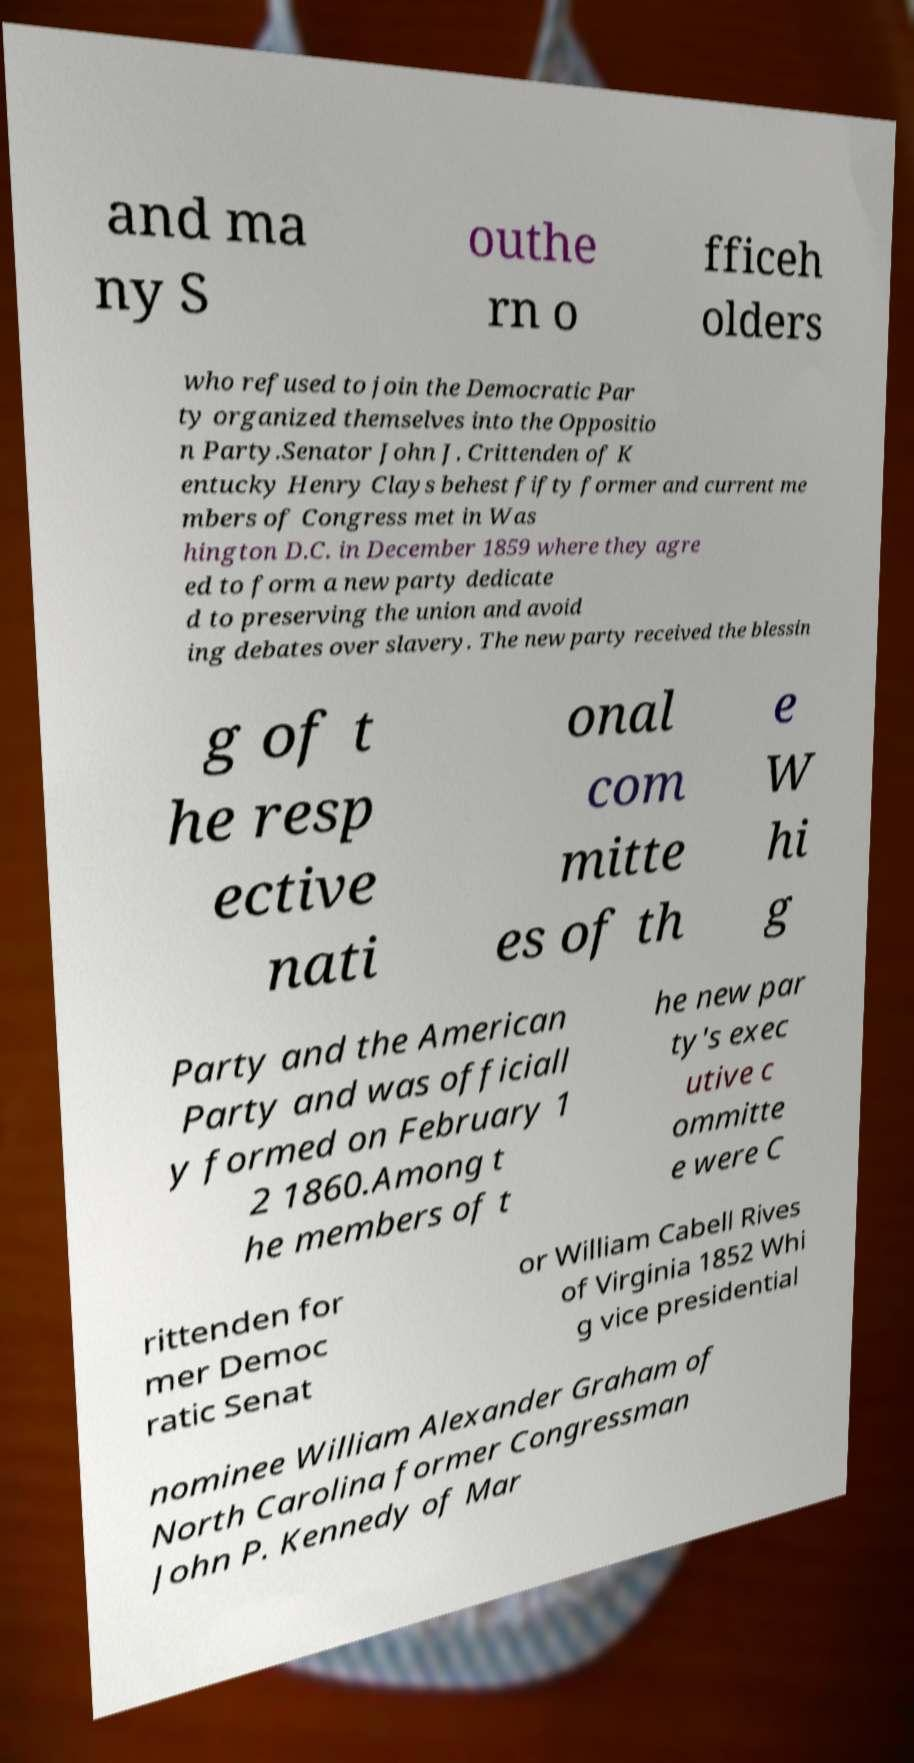Please identify and transcribe the text found in this image. and ma ny S outhe rn o fficeh olders who refused to join the Democratic Par ty organized themselves into the Oppositio n Party.Senator John J. Crittenden of K entucky Henry Clays behest fifty former and current me mbers of Congress met in Was hington D.C. in December 1859 where they agre ed to form a new party dedicate d to preserving the union and avoid ing debates over slavery. The new party received the blessin g of t he resp ective nati onal com mitte es of th e W hi g Party and the American Party and was officiall y formed on February 1 2 1860.Among t he members of t he new par ty's exec utive c ommitte e were C rittenden for mer Democ ratic Senat or William Cabell Rives of Virginia 1852 Whi g vice presidential nominee William Alexander Graham of North Carolina former Congressman John P. Kennedy of Mar 